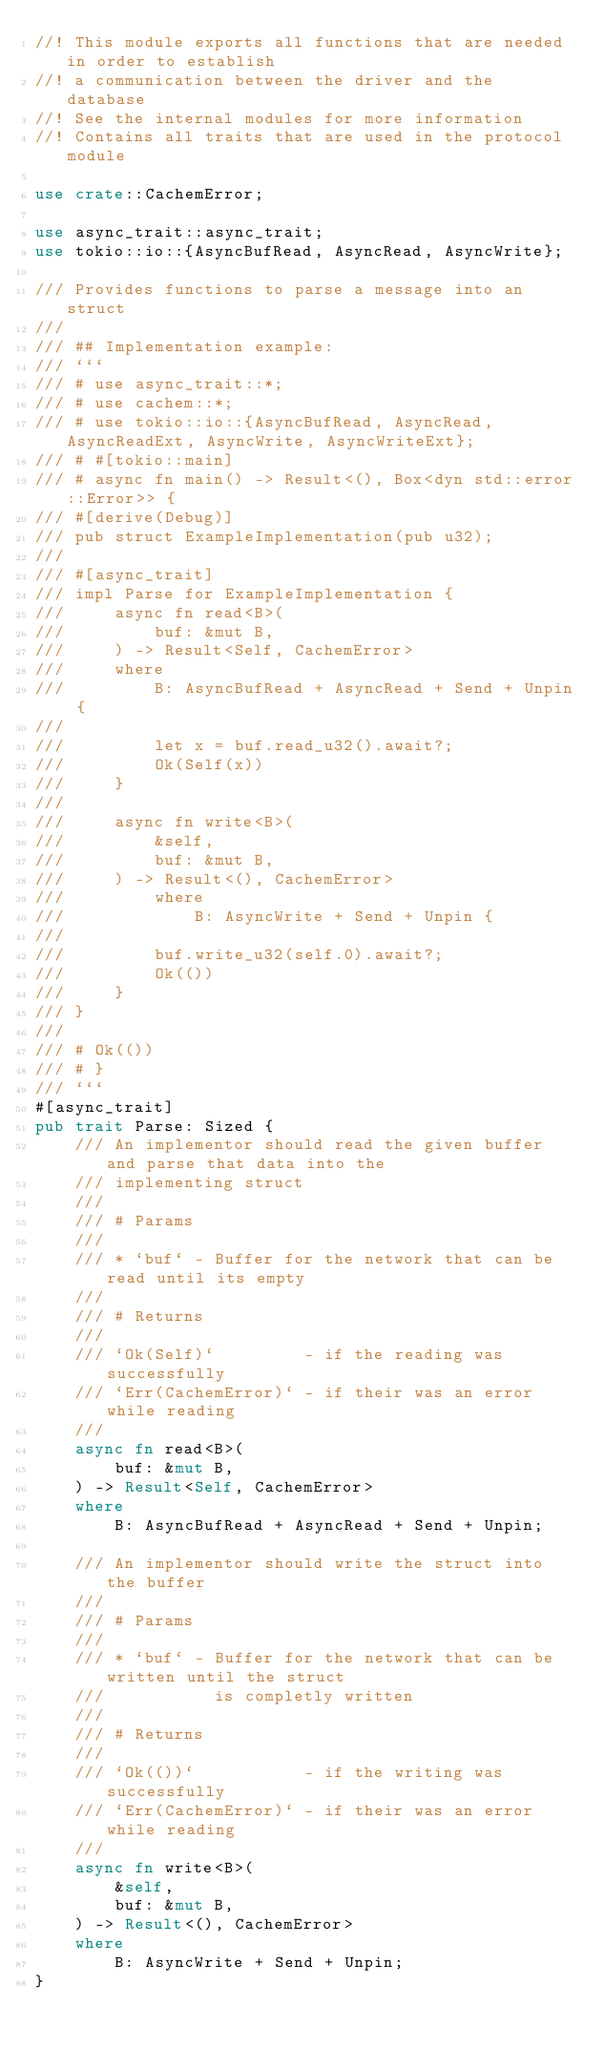Convert code to text. <code><loc_0><loc_0><loc_500><loc_500><_Rust_>//! This module exports all functions that are needed in order to establish
//! a communication between the driver and the database
//! See the internal modules for more information
//! Contains all traits that are used in the protocol module

use crate::CachemError;

use async_trait::async_trait;
use tokio::io::{AsyncBufRead, AsyncRead, AsyncWrite};

/// Provides functions to parse a message into an struct
///
/// ## Implementation example:
/// ```
/// # use async_trait::*;
/// # use cachem::*;
/// # use tokio::io::{AsyncBufRead, AsyncRead, AsyncReadExt, AsyncWrite, AsyncWriteExt};
/// # #[tokio::main]
/// # async fn main() -> Result<(), Box<dyn std::error::Error>> {
/// #[derive(Debug)]
/// pub struct ExampleImplementation(pub u32);
/// 
/// #[async_trait]
/// impl Parse for ExampleImplementation {
///     async fn read<B>(
///         buf: &mut B,
///     ) -> Result<Self, CachemError>
///     where
///         B: AsyncBufRead + AsyncRead + Send + Unpin {
/// 
///         let x = buf.read_u32().await?;
///         Ok(Self(x))
///     }
///
///     async fn write<B>(
///         &self,
///         buf: &mut B,
///     ) -> Result<(), CachemError>
///         where
///             B: AsyncWrite + Send + Unpin {
///
///         buf.write_u32(self.0).await?;
///         Ok(())
///     }
/// }
///
/// # Ok(())
/// # }
/// ```
#[async_trait]
pub trait Parse: Sized {
    /// An implementor should read the given buffer and parse that data into the
    /// implementing struct
    ///
    /// # Params
    ///
    /// * `buf` - Buffer for the network that can be read until its empty
    ///
    /// # Returns
    ///
    /// `Ok(Self)`         - if the reading was successfully
    /// `Err(CachemError)` - if their was an error while reading
    ///
    async fn read<B>(
        buf: &mut B,
    ) -> Result<Self, CachemError>
    where
        B: AsyncBufRead + AsyncRead + Send + Unpin;

    /// An implementor should write the struct into the buffer
    ///
    /// # Params
    ///
    /// * `buf` - Buffer for the network that can be written until the struct
    ///           is completly written
    ///
    /// # Returns
    ///
    /// `Ok(())`           - if the writing was successfully
    /// `Err(CachemError)` - if their was an error while reading
    ///
    async fn write<B>(
        &self,
        buf: &mut B,
    ) -> Result<(), CachemError>
    where
        B: AsyncWrite + Send + Unpin;
}

</code> 